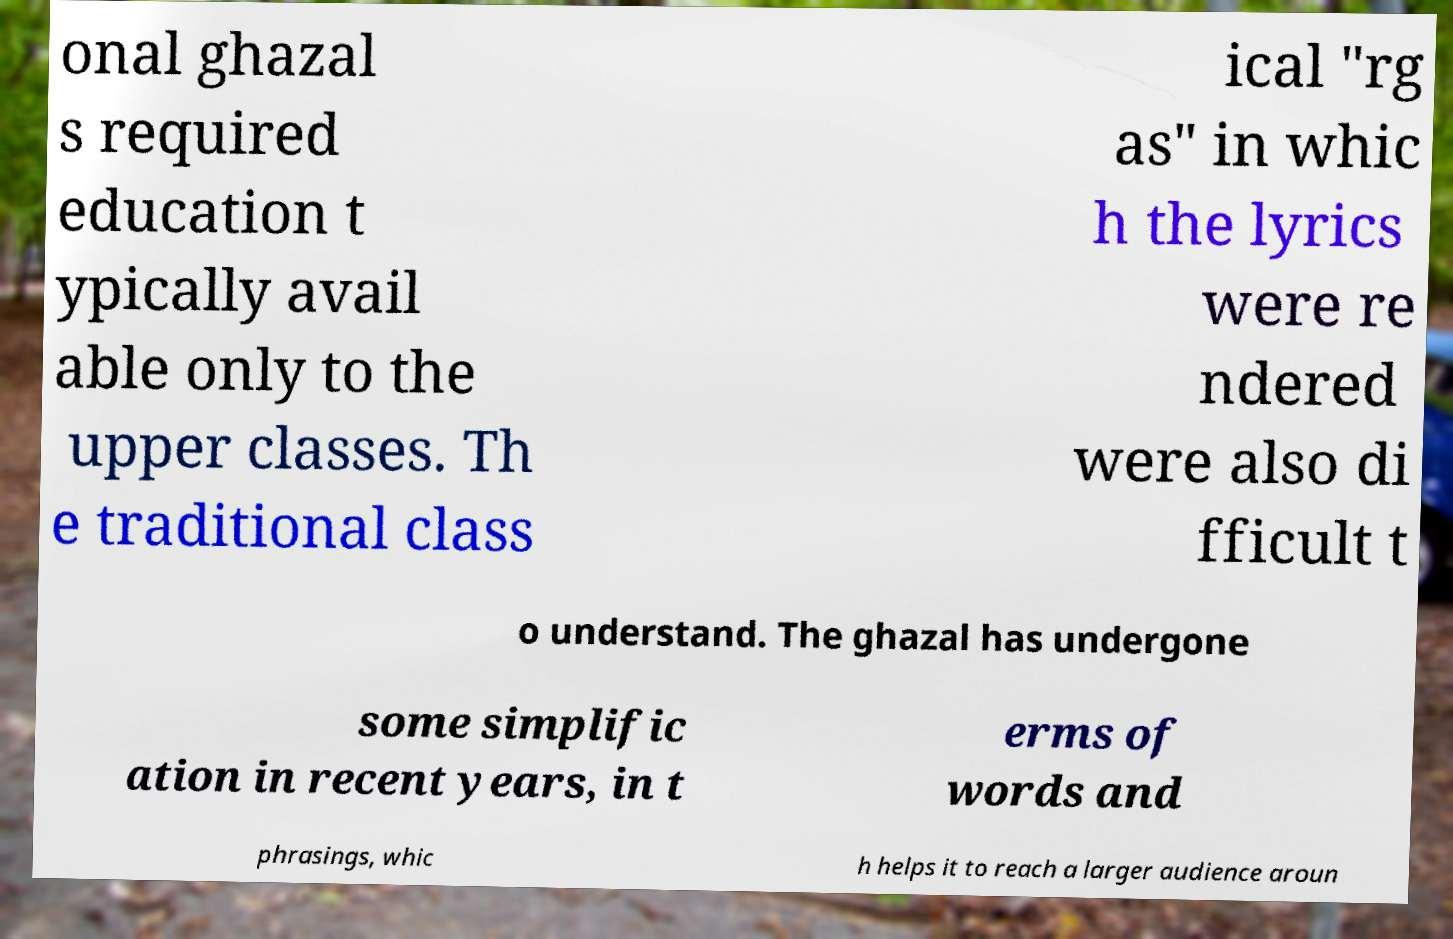Please identify and transcribe the text found in this image. onal ghazal s required education t ypically avail able only to the upper classes. Th e traditional class ical "rg as" in whic h the lyrics were re ndered were also di fficult t o understand. The ghazal has undergone some simplific ation in recent years, in t erms of words and phrasings, whic h helps it to reach a larger audience aroun 